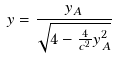Convert formula to latex. <formula><loc_0><loc_0><loc_500><loc_500>y = \frac { y _ { A } } { \sqrt { 4 - \frac { 4 } { c ^ { 2 } } y _ { A } ^ { 2 } } }</formula> 